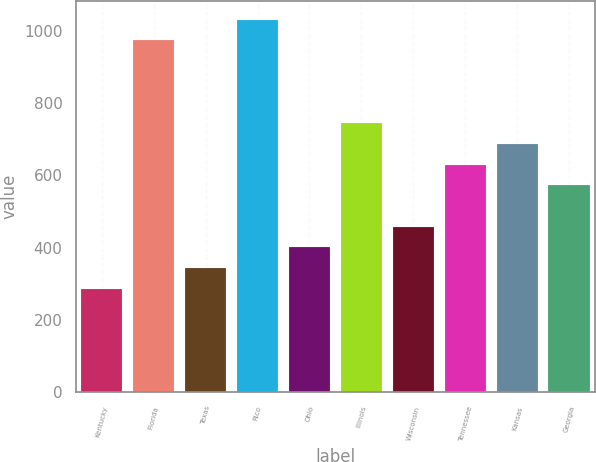Convert chart to OTSL. <chart><loc_0><loc_0><loc_500><loc_500><bar_chart><fcel>Kentucky<fcel>Florida<fcel>Texas<fcel>Rico<fcel>Ohio<fcel>Illinois<fcel>Wisconsin<fcel>Tennessee<fcel>Kansas<fcel>Georgia<nl><fcel>286.29<fcel>973.03<fcel>343.52<fcel>1030.25<fcel>400.75<fcel>744.12<fcel>457.98<fcel>629.67<fcel>686.89<fcel>572.44<nl></chart> 